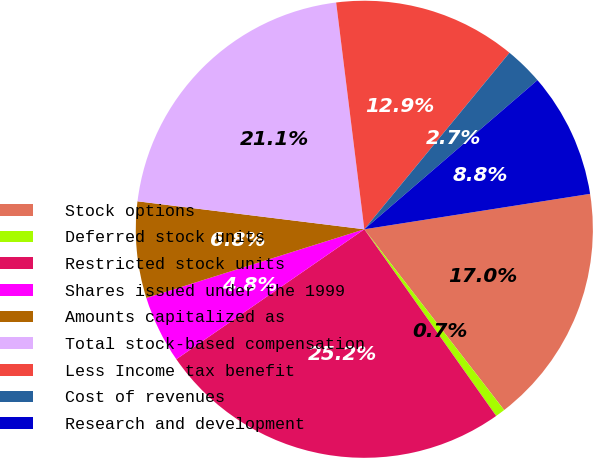<chart> <loc_0><loc_0><loc_500><loc_500><pie_chart><fcel>Stock options<fcel>Deferred stock units<fcel>Restricted stock units<fcel>Shares issued under the 1999<fcel>Amounts capitalized as<fcel>Total stock-based compensation<fcel>Less Income tax benefit<fcel>Cost of revenues<fcel>Research and development<nl><fcel>17.0%<fcel>0.69%<fcel>25.16%<fcel>4.77%<fcel>6.81%<fcel>21.08%<fcel>12.92%<fcel>2.73%<fcel>8.84%<nl></chart> 